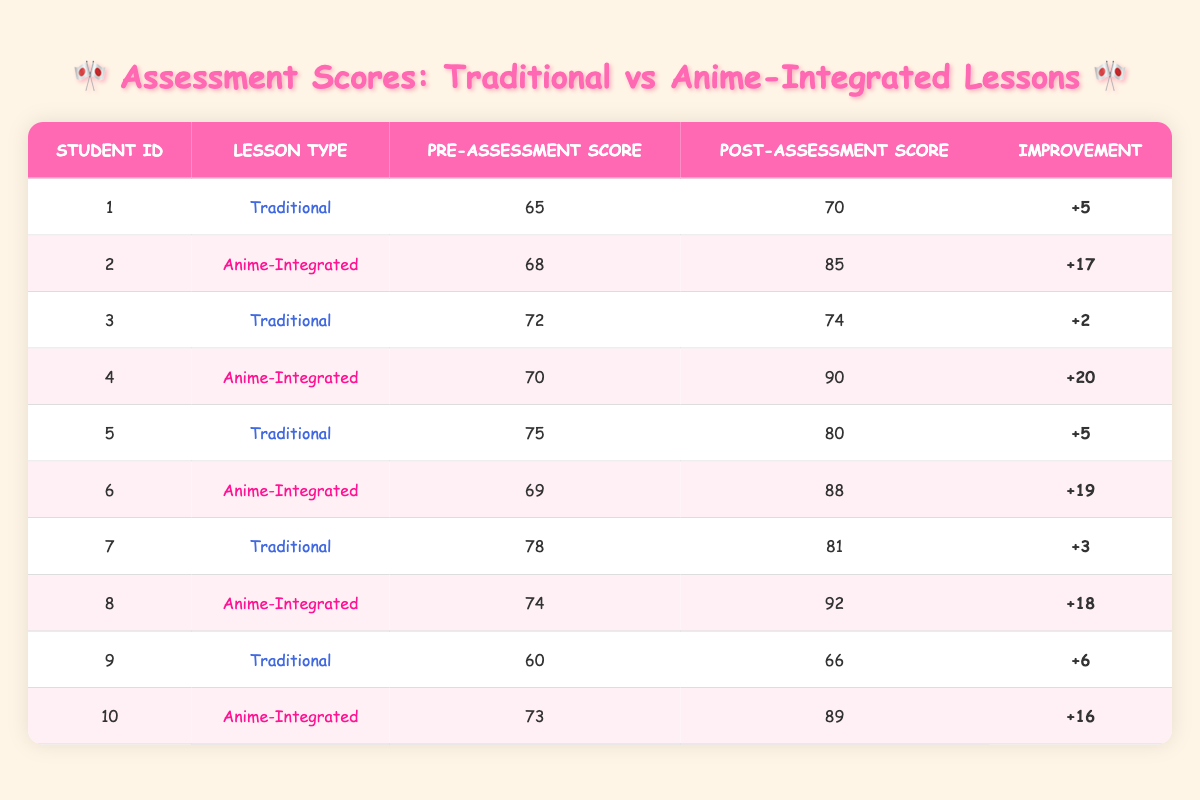What is the highest post-assessment score recorded in the table? The highest post-assessment score can be found by looking at the "Post-Assessment Score" column. Scanning through the values, student 4 has the top score of 90.
Answer: 90 What is the improvement for student 6? The improvement for student 6 is found by subtracting the pre-assessment score from the post-assessment score (88 - 69 = 19).
Answer: 19 How many students had a pre-assessment score above 70? Reviewing the "Pre-Assessment Score" column, the students with scores above 70 are students 3, 5, 7, and 4, totaling 4 students.
Answer: 4 What lesson type had the greatest average improvement? To find the average improvement for each lesson type, first total the improvements for both types. The averages are: Traditional = (5 + 2 + 5 + 3 + 6) / 5 = 4.2; Anime-Integrated = (17 + 20 + 19 + 18 + 16) / 5 = 18.
Answer: Anime-Integrated Is it true that all students in the anime-integrated group improved their scores by more than 10 points? Checking the upgrade values for the anime-integrated students reveals that students 6, 8, and 10 improved by 19, 18, and 16 points respectively, but students 2 and 4 improved by 17 and 20. Thus, all students improved by more than 10 points.
Answer: Yes Which student showed the least improvement, and what was the score? The student with the least improvement can be determined by looking at the "Improvement" column. Student 3 only improved by 2 points.
Answer: Student 3, 2 points What is the total improvement for all traditional lessons combined? To find the total improvement for traditional lessons, sum the improvements: 5 + 2 + 5 + 3 + 6, which equals 21.
Answer: 21 Which type of lesson shows a higher minimum score in the post-assessment? By comparing both types in the "Post-Assessment Score" column, the minimum for traditional is 66 (student 9) and for anime-integrated is 85 (student 2); since 85 is greater, anime-integrated has a higher minimum score.
Answer: Anime-Integrated 